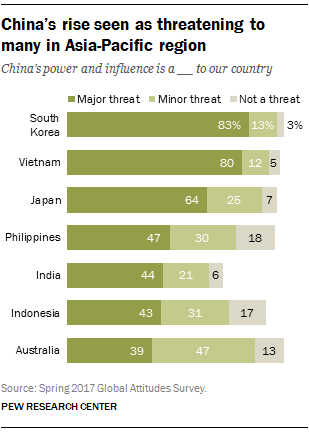Mention a couple of crucial points in this snapshot. The major threat distribution between India and Indonesia is 87. There are three colors in the bar. 